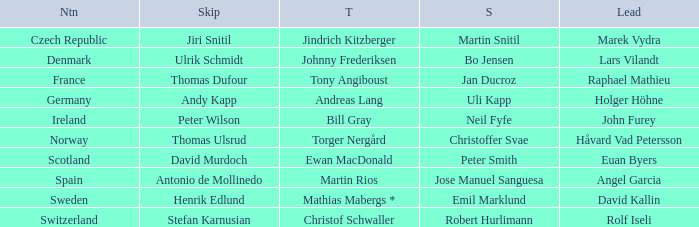Help me parse the entirety of this table. {'header': ['Ntn', 'Skip', 'T', 'S', 'Lead'], 'rows': [['Czech Republic', 'Jiri Snitil', 'Jindrich Kitzberger', 'Martin Snitil', 'Marek Vydra'], ['Denmark', 'Ulrik Schmidt', 'Johnny Frederiksen', 'Bo Jensen', 'Lars Vilandt'], ['France', 'Thomas Dufour', 'Tony Angiboust', 'Jan Ducroz', 'Raphael Mathieu'], ['Germany', 'Andy Kapp', 'Andreas Lang', 'Uli Kapp', 'Holger Höhne'], ['Ireland', 'Peter Wilson', 'Bill Gray', 'Neil Fyfe', 'John Furey'], ['Norway', 'Thomas Ulsrud', 'Torger Nergård', 'Christoffer Svae', 'Håvard Vad Petersson'], ['Scotland', 'David Murdoch', 'Ewan MacDonald', 'Peter Smith', 'Euan Byers'], ['Spain', 'Antonio de Mollinedo', 'Martin Rios', 'Jose Manuel Sanguesa', 'Angel Garcia'], ['Sweden', 'Henrik Edlund', 'Mathias Mabergs *', 'Emil Marklund', 'David Kallin'], ['Switzerland', 'Stefan Karnusian', 'Christof Schwaller', 'Robert Hurlimann', 'Rolf Iseli']]} When did France come in second? Jan Ducroz. 